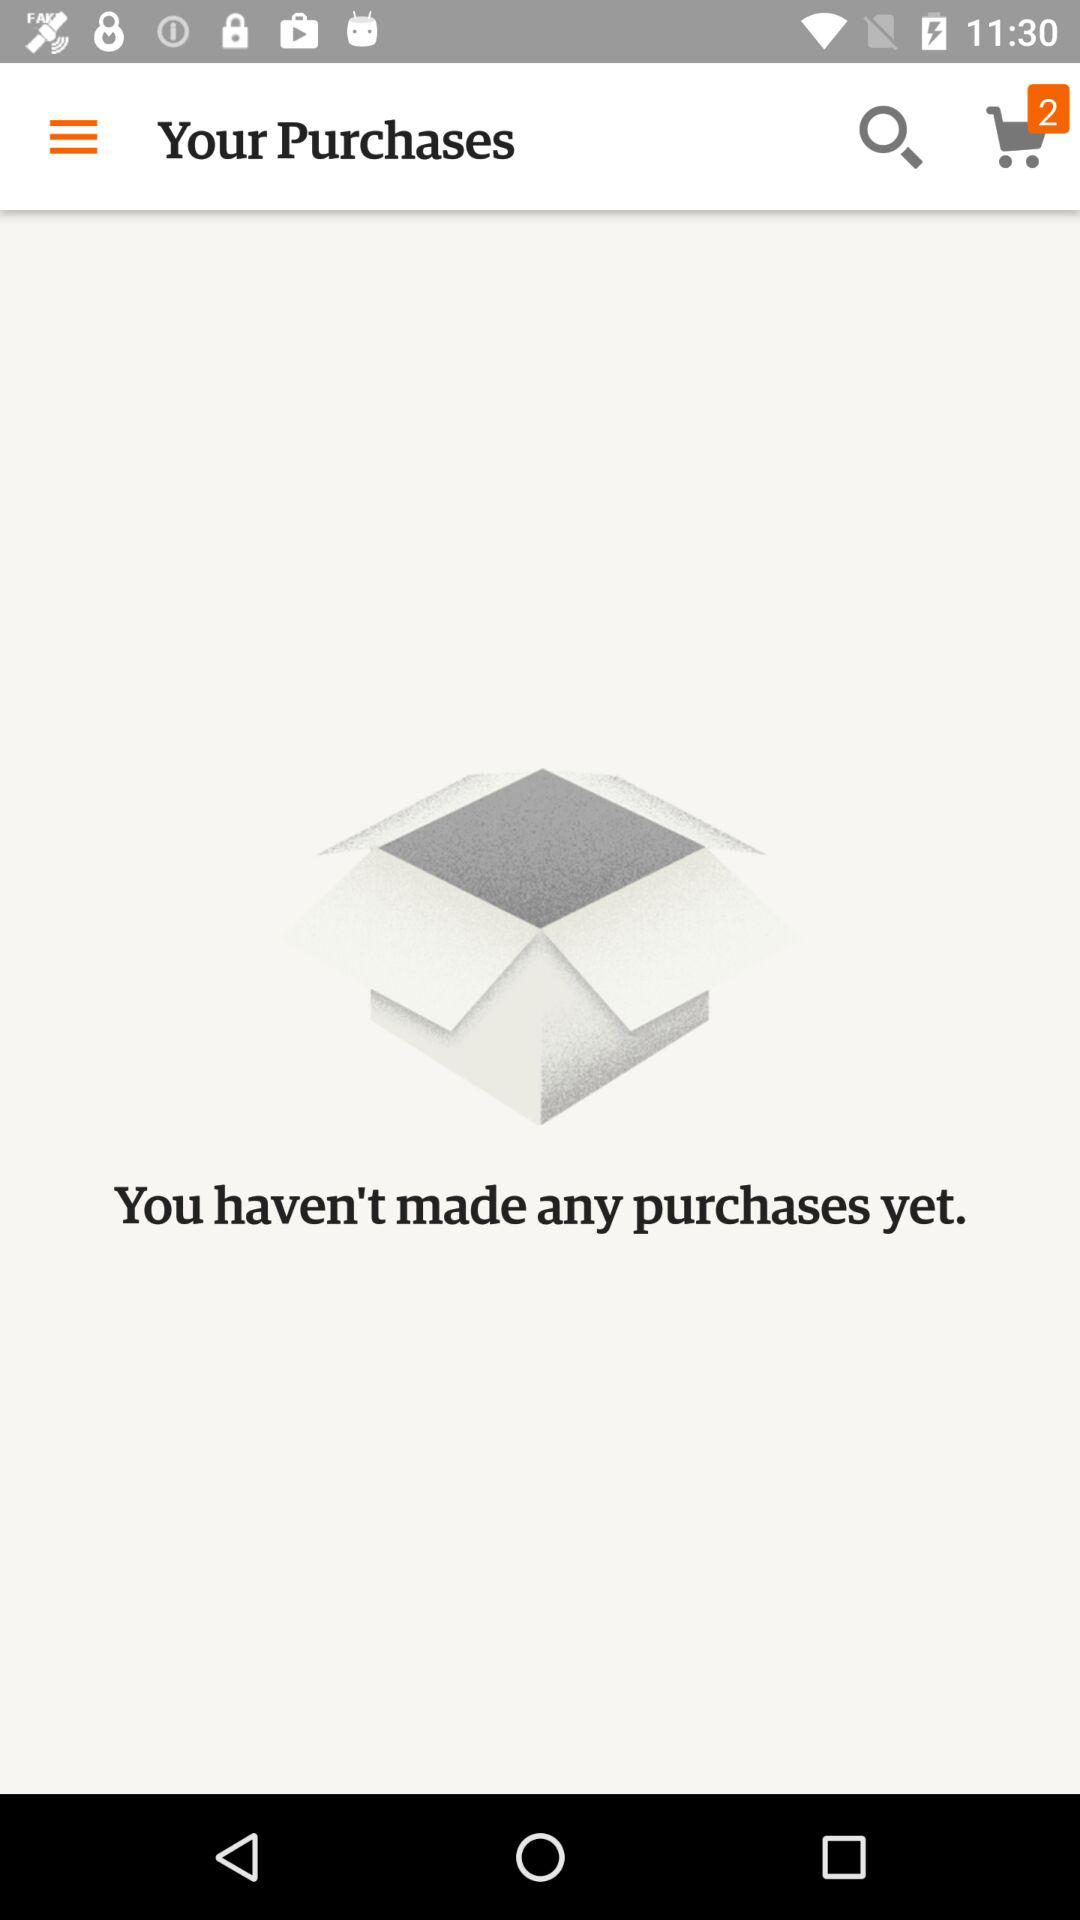How many items are added to the cart? There are 2 items. 